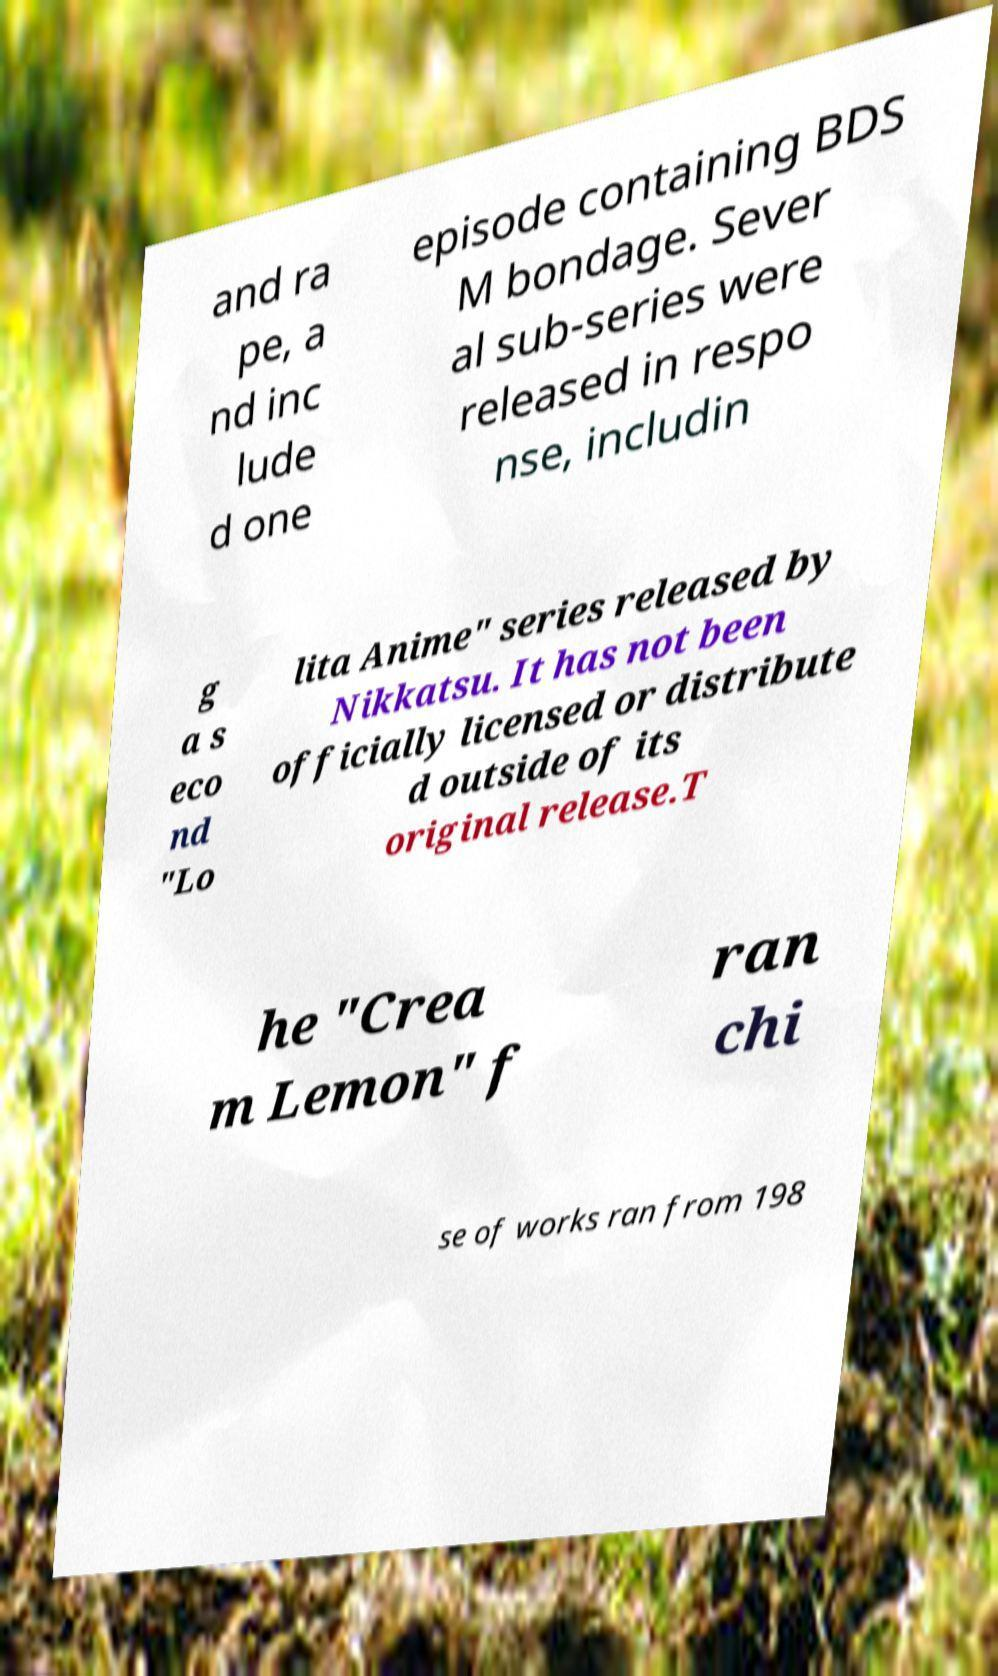What messages or text are displayed in this image? I need them in a readable, typed format. and ra pe, a nd inc lude d one episode containing BDS M bondage. Sever al sub-series were released in respo nse, includin g a s eco nd "Lo lita Anime" series released by Nikkatsu. It has not been officially licensed or distribute d outside of its original release.T he "Crea m Lemon" f ran chi se of works ran from 198 